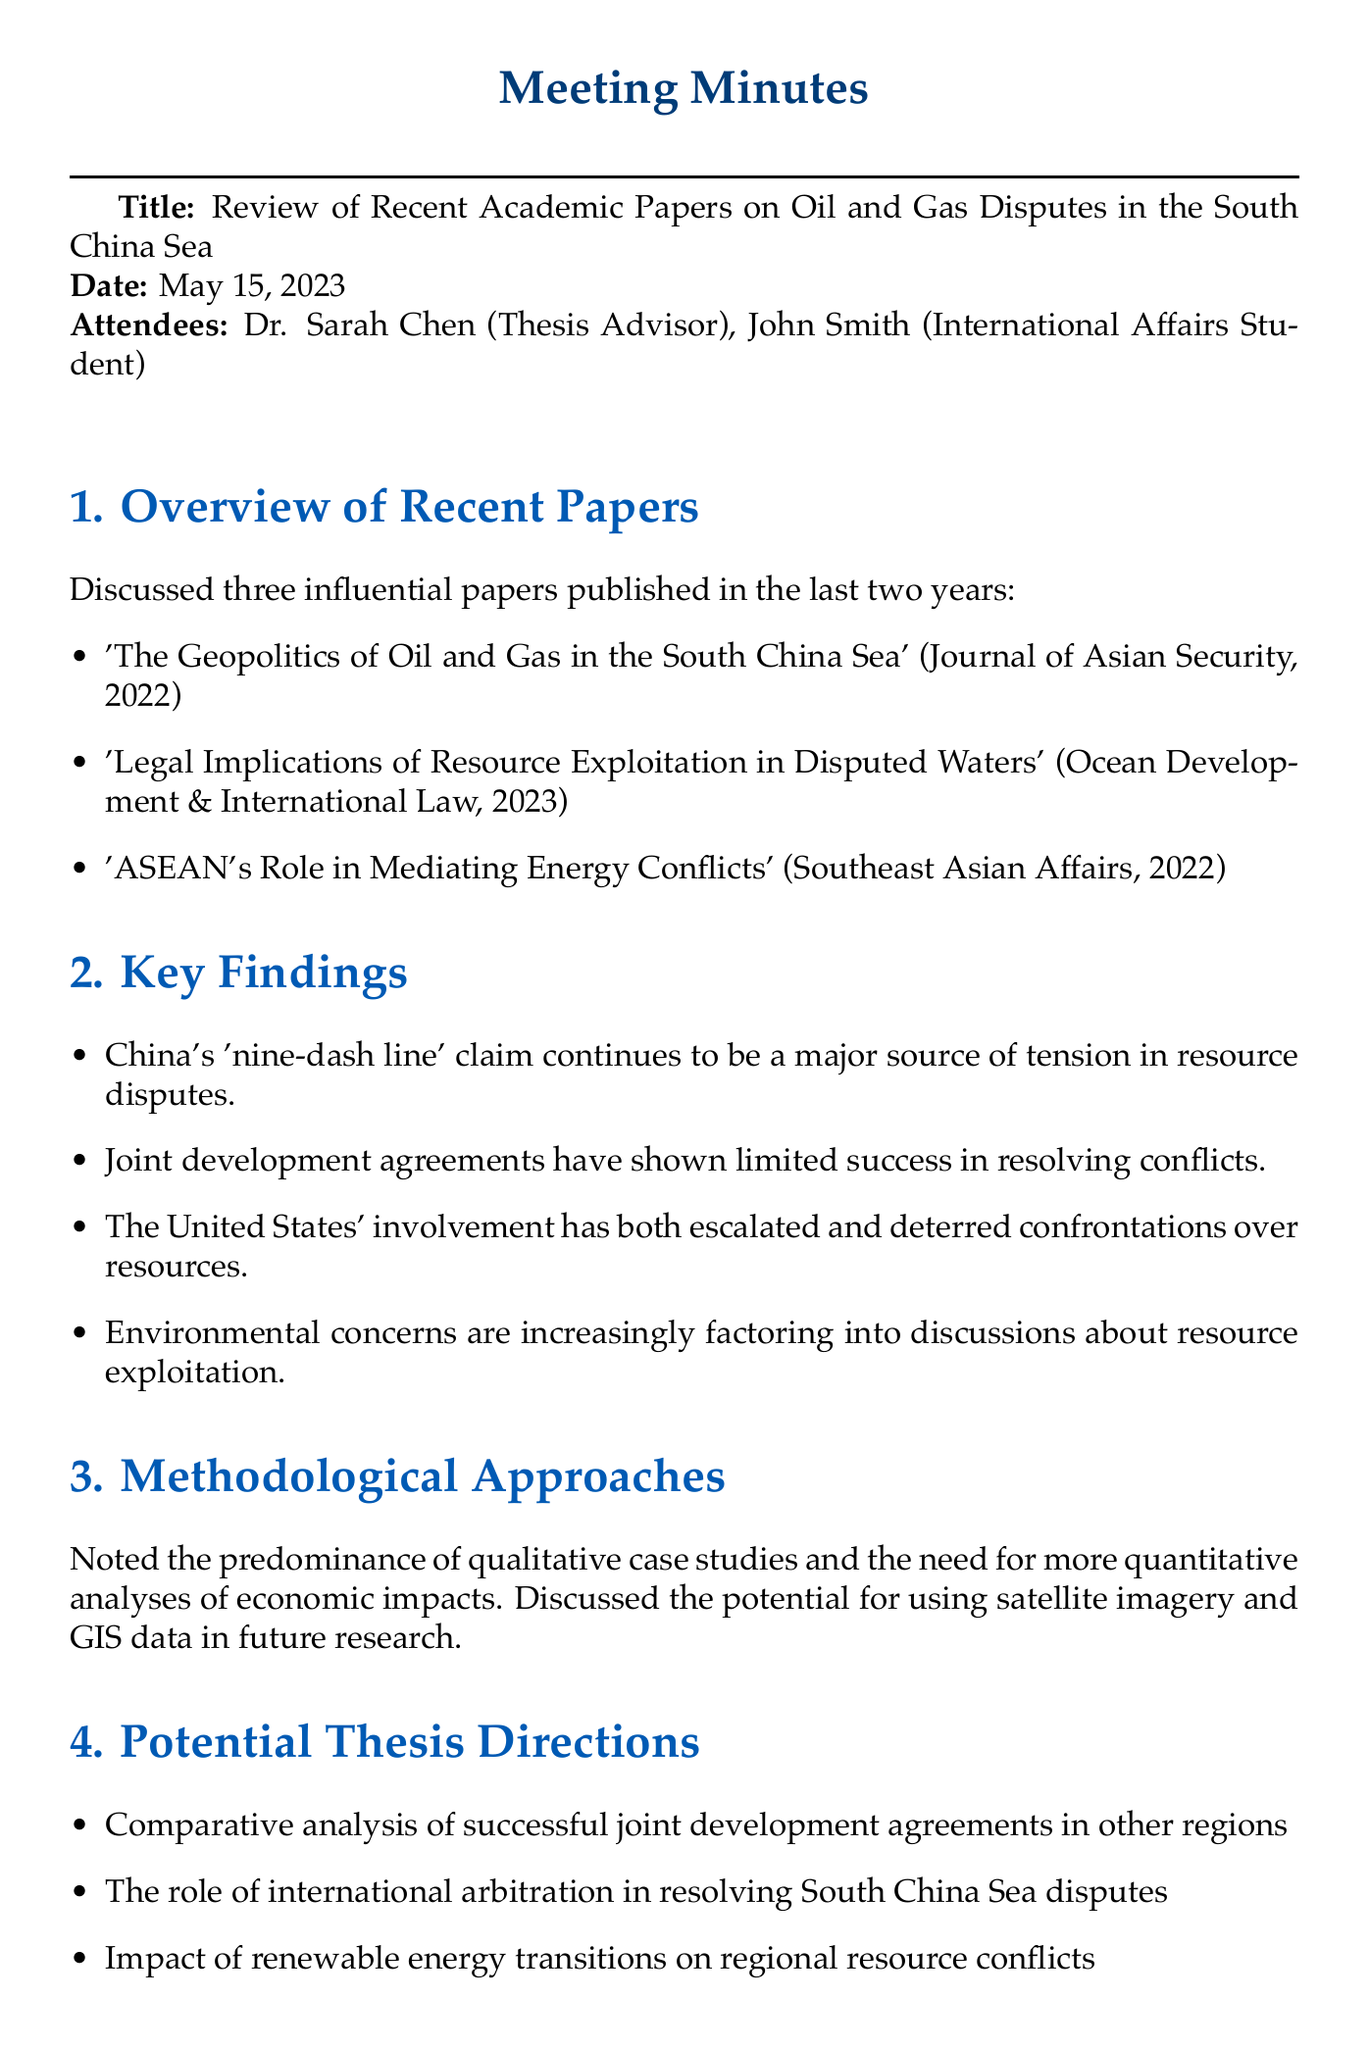What is the title of the meeting? The title of the meeting is stated at the beginning of the document.
Answer: Review of Recent Academic Papers on Oil and Gas Disputes in the South China Sea Who is the thesis advisor mentioned in the meeting? The document lists the attendees, including their roles.
Answer: Dr. Sarah Chen What are the three papers discussed in the meeting? The document provides a list of the three influential papers covered in the agenda.
Answer: 'The Geopolitics of Oil and Gas in the South China Sea', 'Legal Implications of Resource Exploitation in Disputed Waters', 'ASEAN's Role in Mediating Energy Conflicts' What was one of the key findings regarding China's claims? Key findings include insights into geopolitical tensions stemming from specific claims.
Answer: China's 'nine-dash line' claim continues to be a major source of tension in resource disputes What methodological approach was noted as predominant? The document points out the prevailing research methods discussed in the meeting.
Answer: Qualitative case studies What is one potential thesis direction mentioned? The document outlines several directions that could be taken for thesis research.
Answer: Comparative analysis of successful joint development agreements in other regions How many attendees were present at the meeting? The document explicitly mentions the participants of the meeting.
Answer: 2 What will John Smith prepare for the next meeting? The next steps section outlines the tasks assigned to John Smith.
Answer: A preliminary thesis proposal 